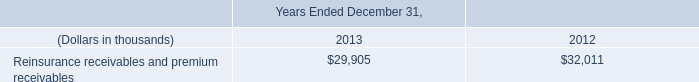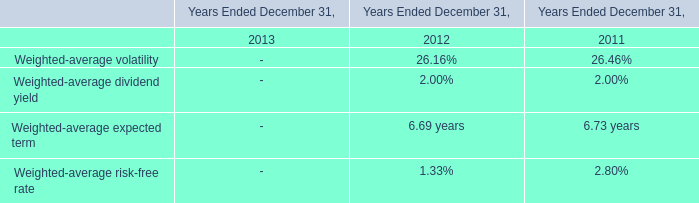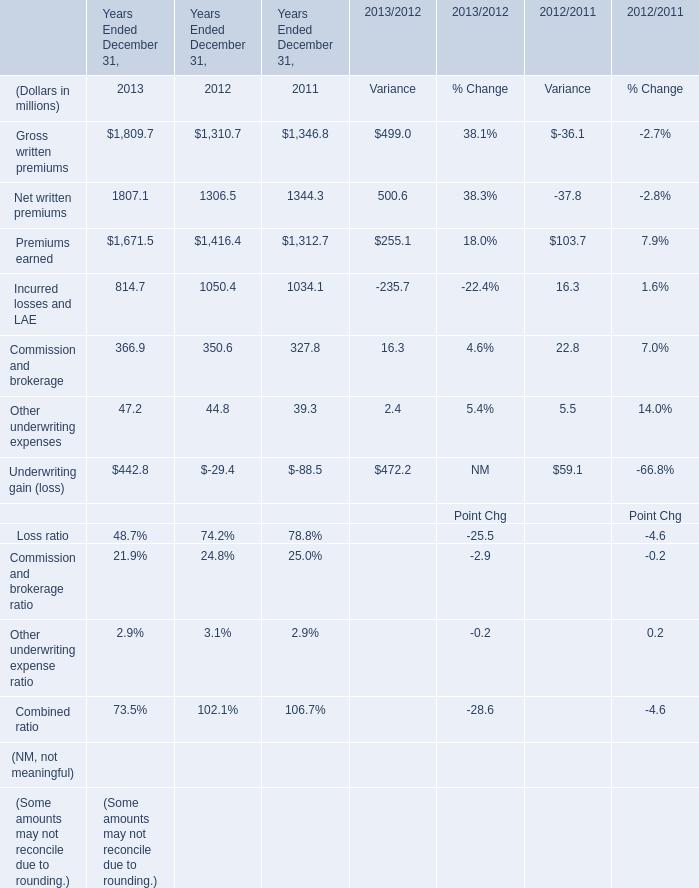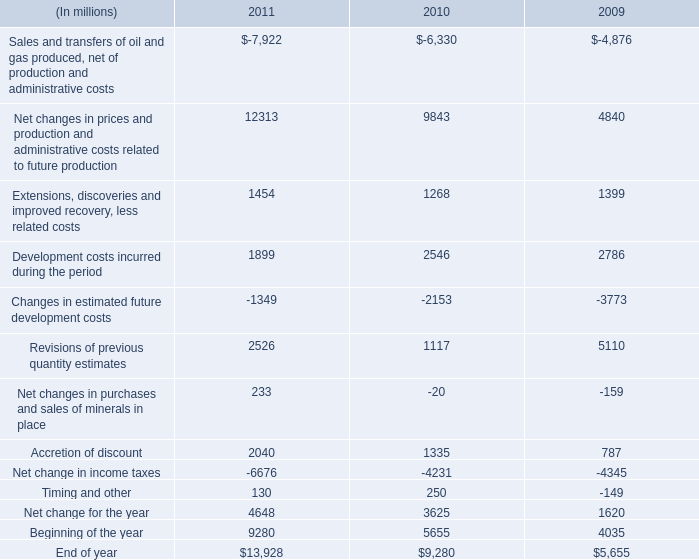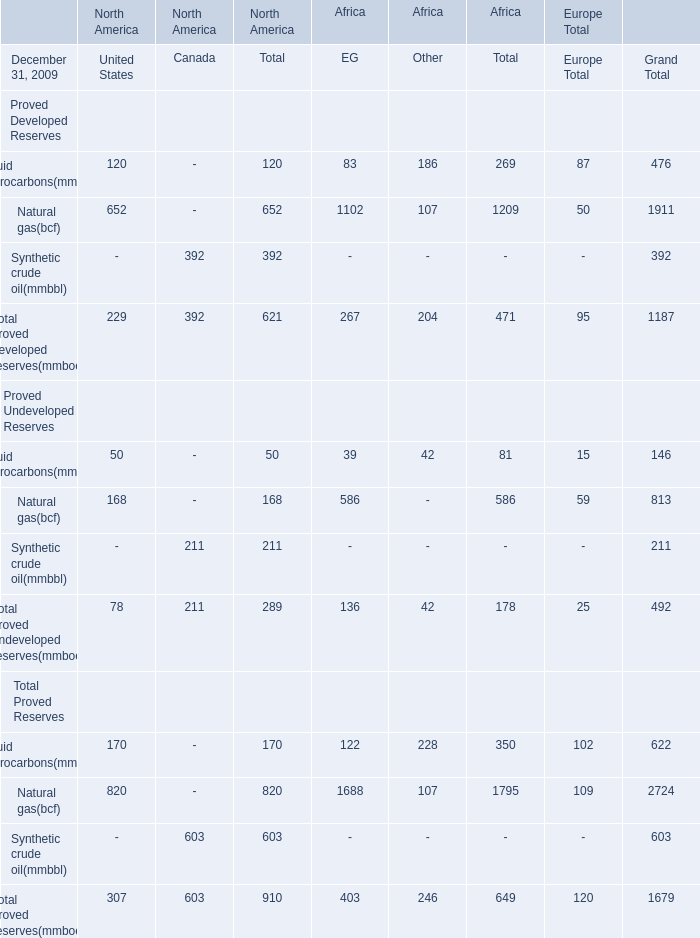What is the average amount of Net change in income taxes of 2011, and Premiums earned of Years Ended December 31, 2011 ? 
Computations: ((6676.0 + 1312.7) / 2)
Answer: 3994.35. 